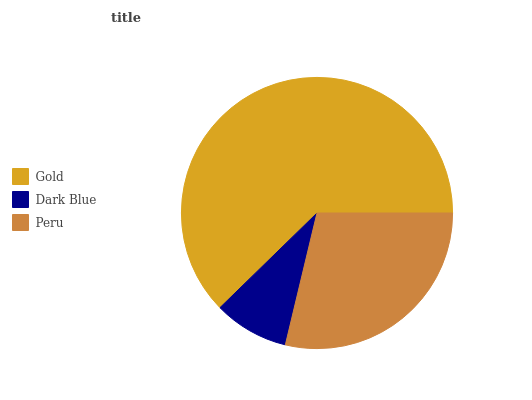Is Dark Blue the minimum?
Answer yes or no. Yes. Is Gold the maximum?
Answer yes or no. Yes. Is Peru the minimum?
Answer yes or no. No. Is Peru the maximum?
Answer yes or no. No. Is Peru greater than Dark Blue?
Answer yes or no. Yes. Is Dark Blue less than Peru?
Answer yes or no. Yes. Is Dark Blue greater than Peru?
Answer yes or no. No. Is Peru less than Dark Blue?
Answer yes or no. No. Is Peru the high median?
Answer yes or no. Yes. Is Peru the low median?
Answer yes or no. Yes. Is Dark Blue the high median?
Answer yes or no. No. Is Gold the low median?
Answer yes or no. No. 